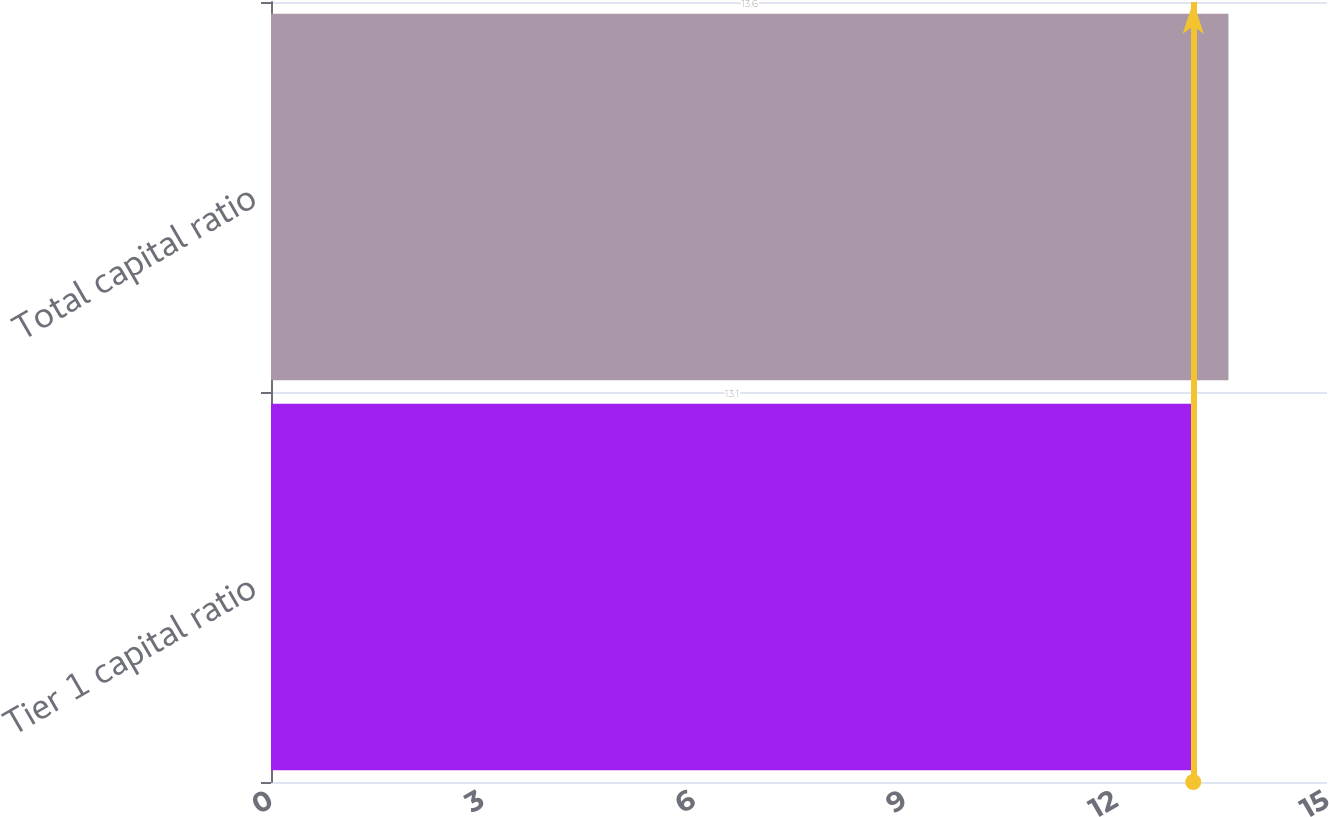Convert chart. <chart><loc_0><loc_0><loc_500><loc_500><bar_chart><fcel>Tier 1 capital ratio<fcel>Total capital ratio<nl><fcel>13.1<fcel>13.6<nl></chart> 